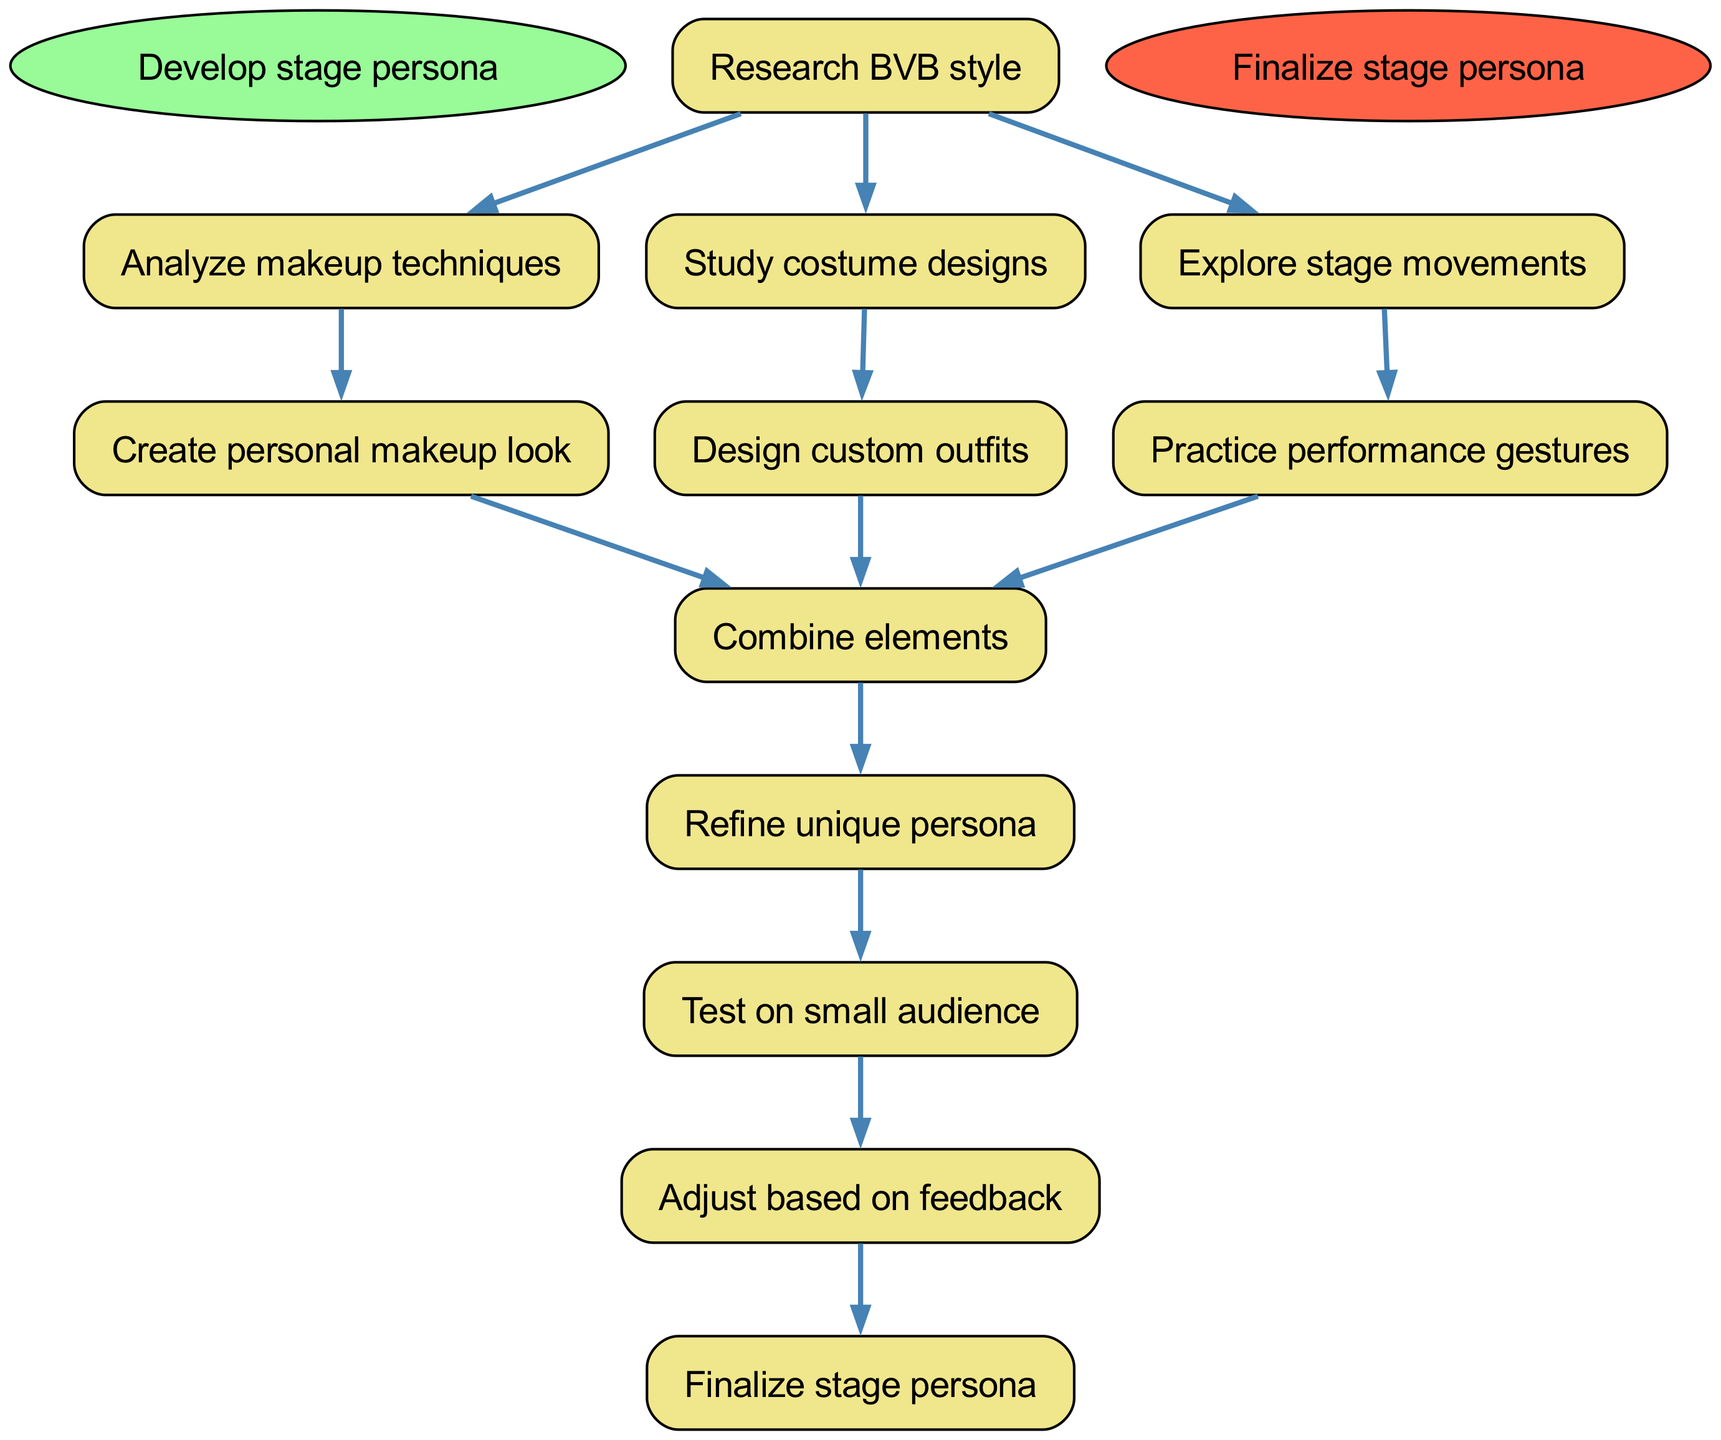What is the first step in the flowchart? The flowchart begins with the "Develop stage persona" node, which indicates the starting point of the process.
Answer: Develop stage persona How many steps are connected to "Research BVB style"? The "Research BVB style" node connects to three subsequent steps: "Analyze makeup techniques," "Study costume designs," and "Explore stage movements," totaling three connections.
Answer: 3 What comes after "Create personal makeup look"? Following the "Create personal makeup look" step, the next step indicated is "Combine elements," which continues the process of developing the stage persona.
Answer: Combine elements Which step leads directly to the "Refine unique persona"? The steps "Combine elements" from multiple nodes—"Create personal makeup look," "Design custom outfits," and "Practice performance gestures"—lead to the "Refine unique persona" step, merging multiple creative aspects into a singular presentation.
Answer: Combine elements What is the final step of the flowchart? The process concludes with the "Finalize stage persona" step, which signifies the completion of the stage persona development journey.
Answer: Finalize stage persona How many total steps are in the flowchart? By counting each individual step presented in the flowchart, starting from "Develop stage persona" to "Finalize stage persona," there are a total of 11 steps.
Answer: 11 Which node leads to "Adjust based on feedback"? The "Test on small audience" step connects directly to the "Adjust based on feedback" node, indicating that audience input is crucial for refining the stage persona.
Answer: Test on small audience Identify a node that directly connects to two other nodes. The "Combine elements" node directly connects to three subsequent nodes: "Refine unique persona," indicating its importance in synthesizing different aspects of the stage persona.
Answer: Combine elements 